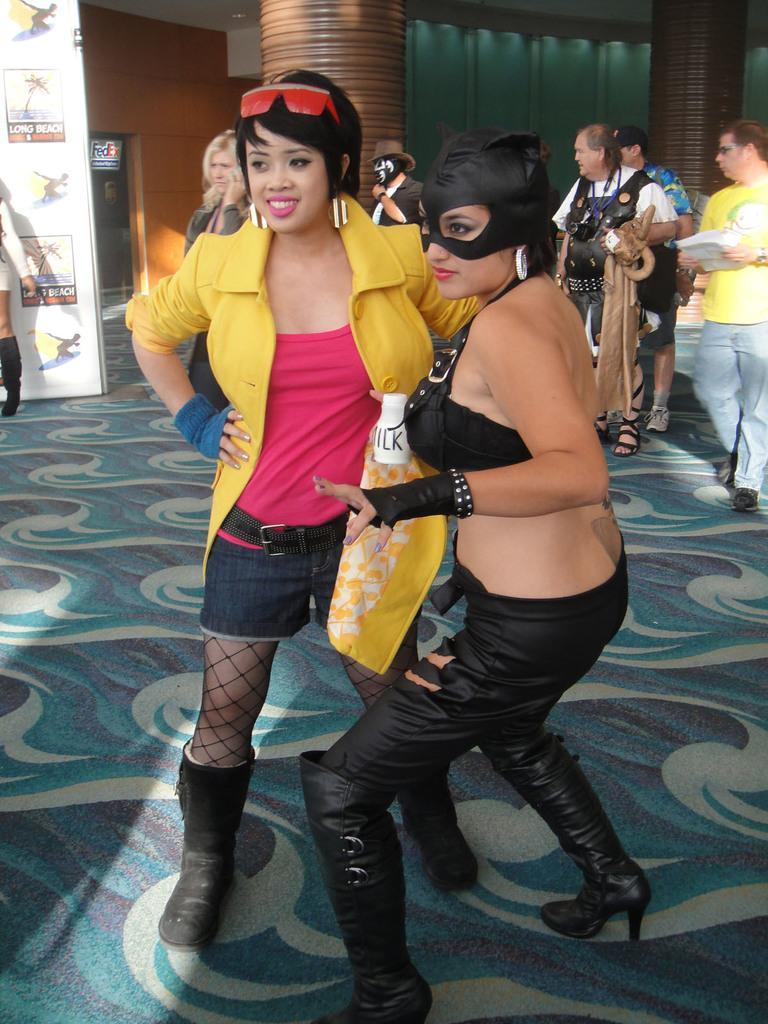How would you summarize this image in a sentence or two? In this image we can see a group of people standing on the ground. In the foreground we can see two women wearing costumes. One woman is wearing goggles on her head. In the background, we can see a poster with some text and some pictures, a building with a door ,two pillars and some lights. 